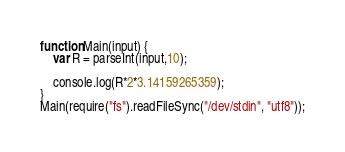Convert code to text. <code><loc_0><loc_0><loc_500><loc_500><_JavaScript_>function Main(input) {
    var R = parseInt(input,10);
   
    console.log(R*2*3.14159265359);
}
Main(require("fs").readFileSync("/dev/stdin", "utf8"));</code> 